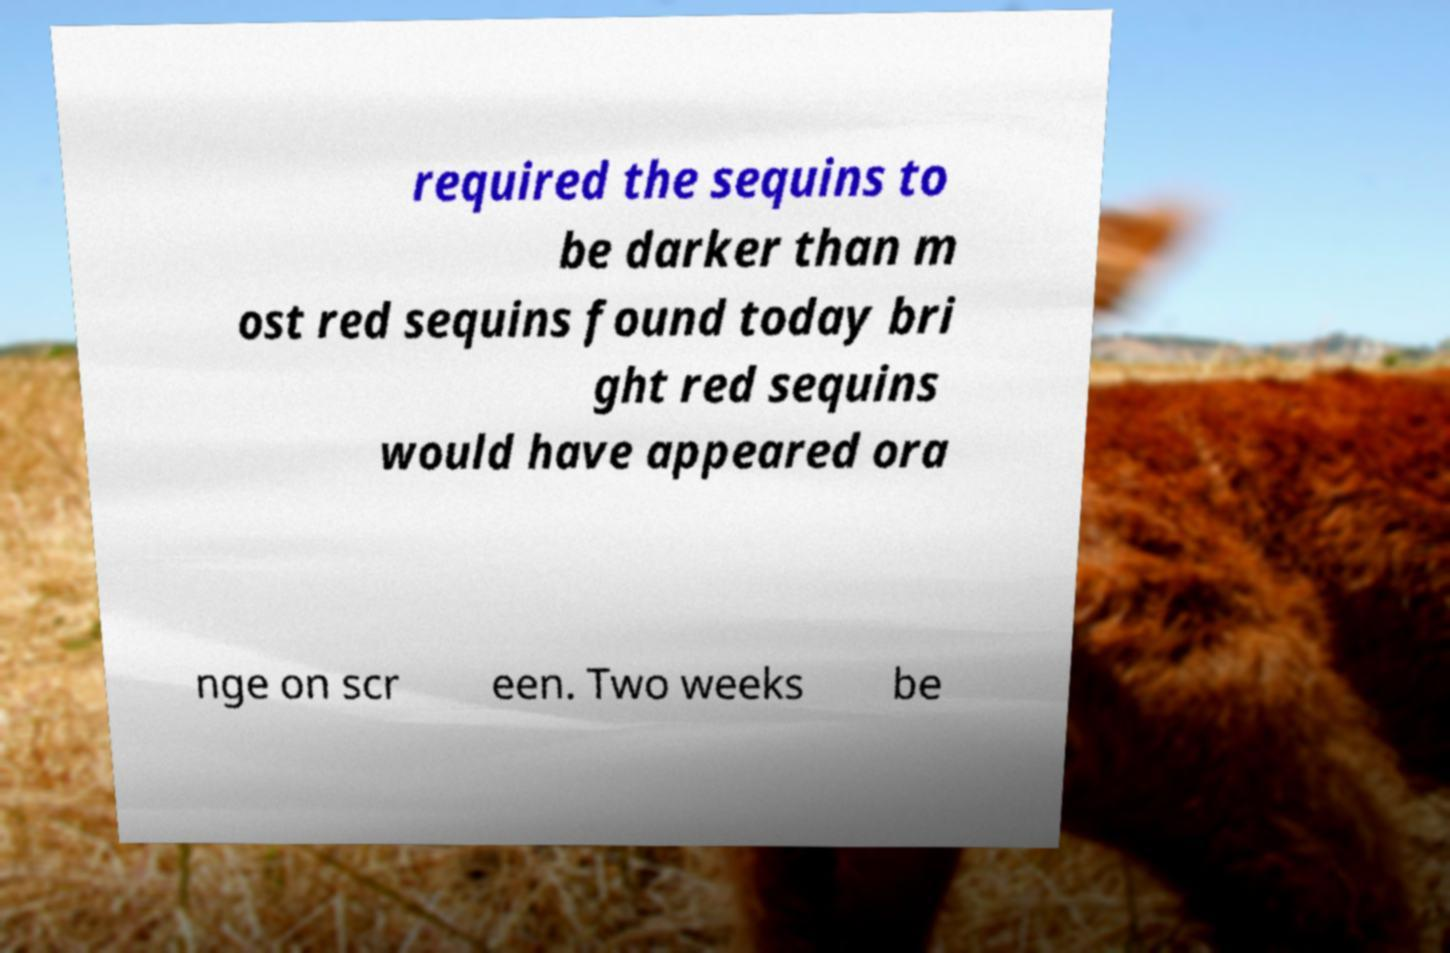Could you extract and type out the text from this image? required the sequins to be darker than m ost red sequins found today bri ght red sequins would have appeared ora nge on scr een. Two weeks be 